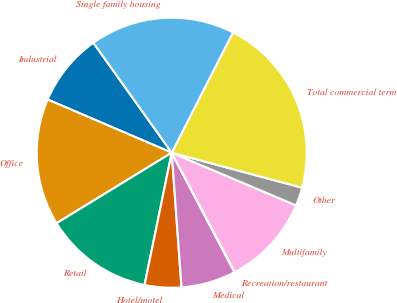<chart> <loc_0><loc_0><loc_500><loc_500><pie_chart><fcel>Industrial<fcel>Office<fcel>Retail<fcel>Hotel/motel<fcel>Medical<fcel>Recreation/restaurant<fcel>Multifamily<fcel>Other<fcel>Total commercial term<fcel>Single family housing<nl><fcel>8.7%<fcel>15.19%<fcel>13.03%<fcel>4.38%<fcel>6.54%<fcel>0.05%<fcel>10.87%<fcel>2.21%<fcel>21.68%<fcel>17.35%<nl></chart> 